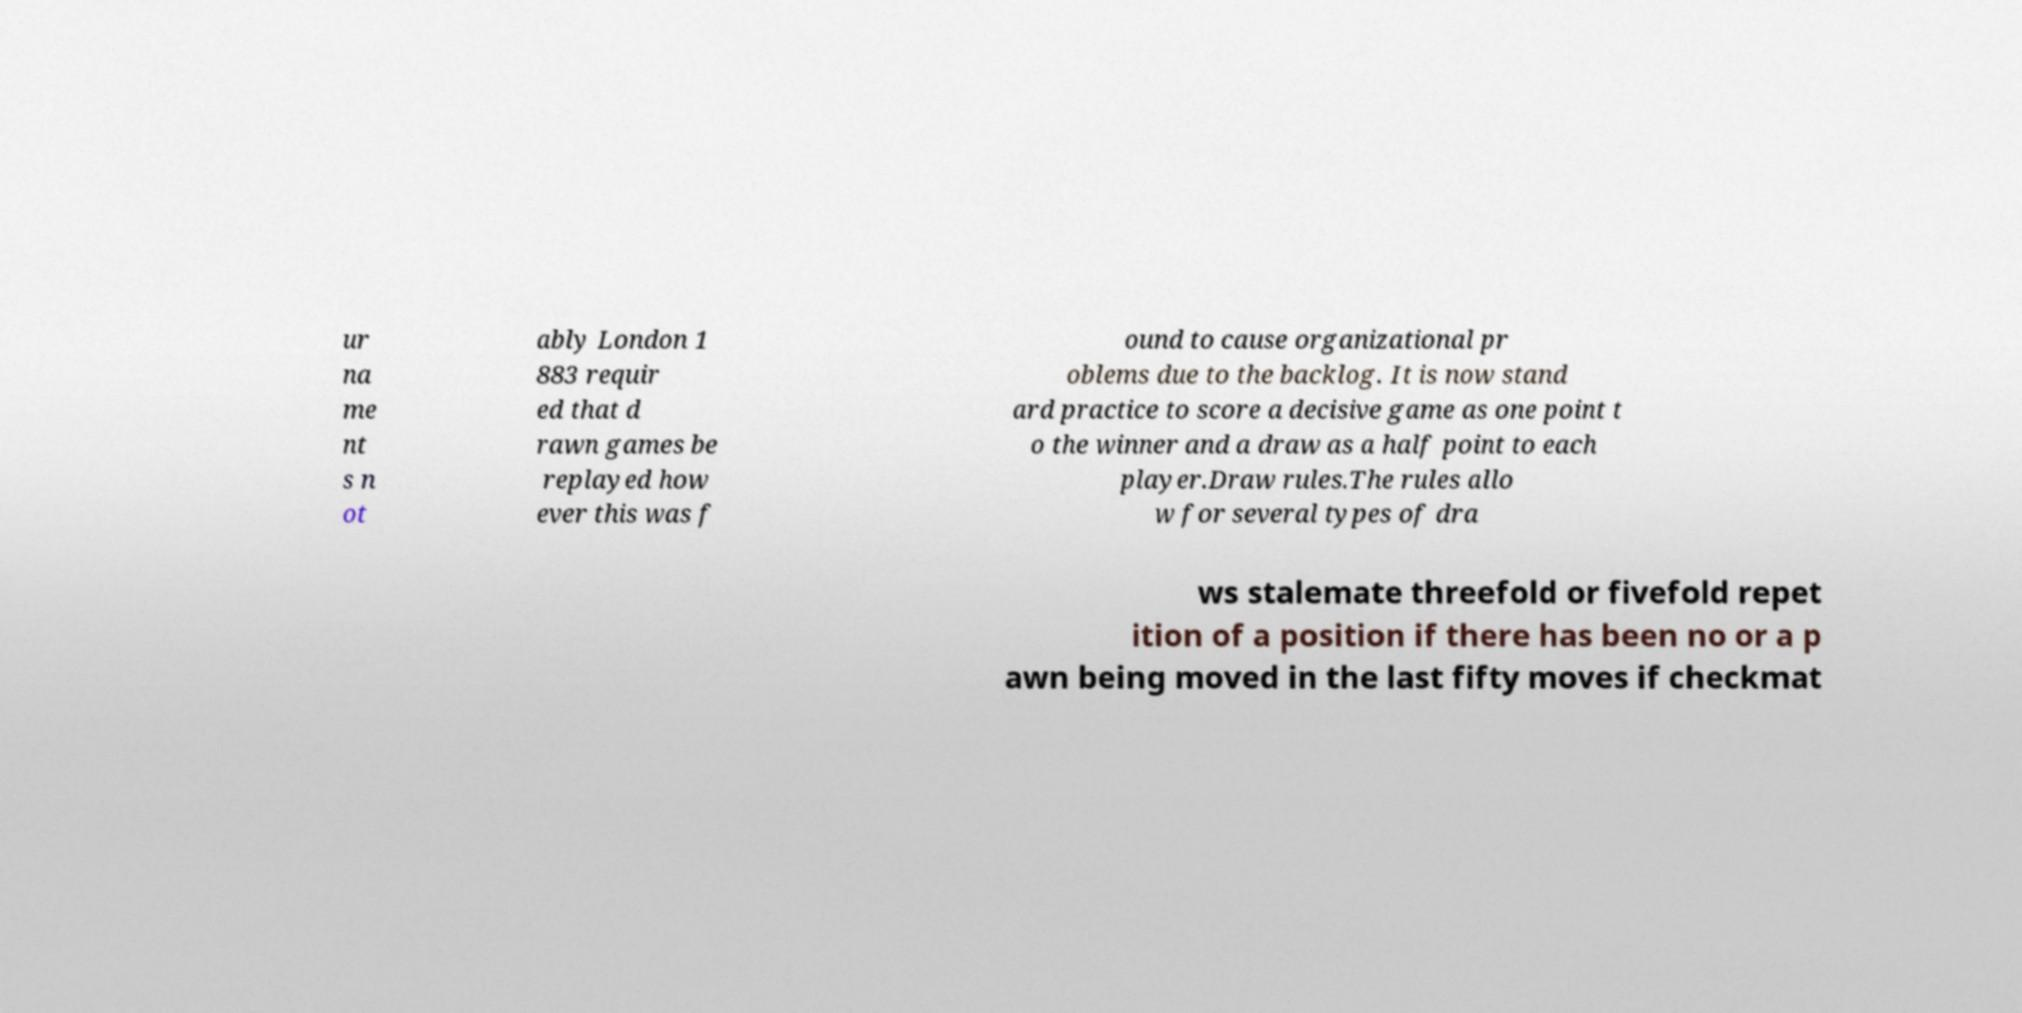For documentation purposes, I need the text within this image transcribed. Could you provide that? ur na me nt s n ot ably London 1 883 requir ed that d rawn games be replayed how ever this was f ound to cause organizational pr oblems due to the backlog. It is now stand ard practice to score a decisive game as one point t o the winner and a draw as a half point to each player.Draw rules.The rules allo w for several types of dra ws stalemate threefold or fivefold repet ition of a position if there has been no or a p awn being moved in the last fifty moves if checkmat 